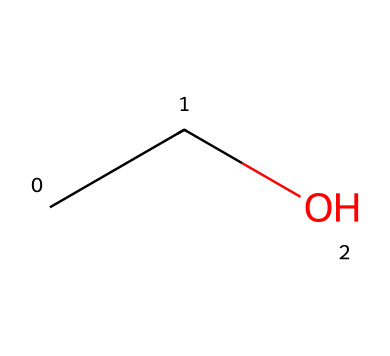What is the name of this compound? The given SMILES representation (CCO) corresponds to ethanol, which is commonly known as alcohol. The two carbon atoms (C) and the hydroxyl group (O) lead to the name ethanol.
Answer: ethanol How many carbon atoms are present in this compound? By examining the SMILES representation (CCO), it is clear there are two carbon atoms represented by the two 'C's.
Answer: 2 How many hydrogen atoms are in ethanol? Ethanol (CCO) has a total molecular formula of C2H6O. From the structure, we can deduce there are six hydrogen atoms attached to the two carbon atoms and the hydroxyl group.
Answer: 6 What type of functional group is present in ethanol? The SMILES structure shows a hydroxyl group (-OH) connected to a carbon atom. This specific group is characteristic of alcohols.
Answer: hydroxyl How does ethanol affect decision-making? Ethanol is known to impair cognitive functions and reduce inhibitions, leading to poor decision-making, as evidence suggests that alcohol affects neurotransmitter systems.
Answer: impair Is ethanol considered a hydrocarbon? Although ethanol contains carbon and hydrogen, it has an oxygen atom due to the hydroxyl group, making it an alcohol and not a pure hydrocarbon.
Answer: no 